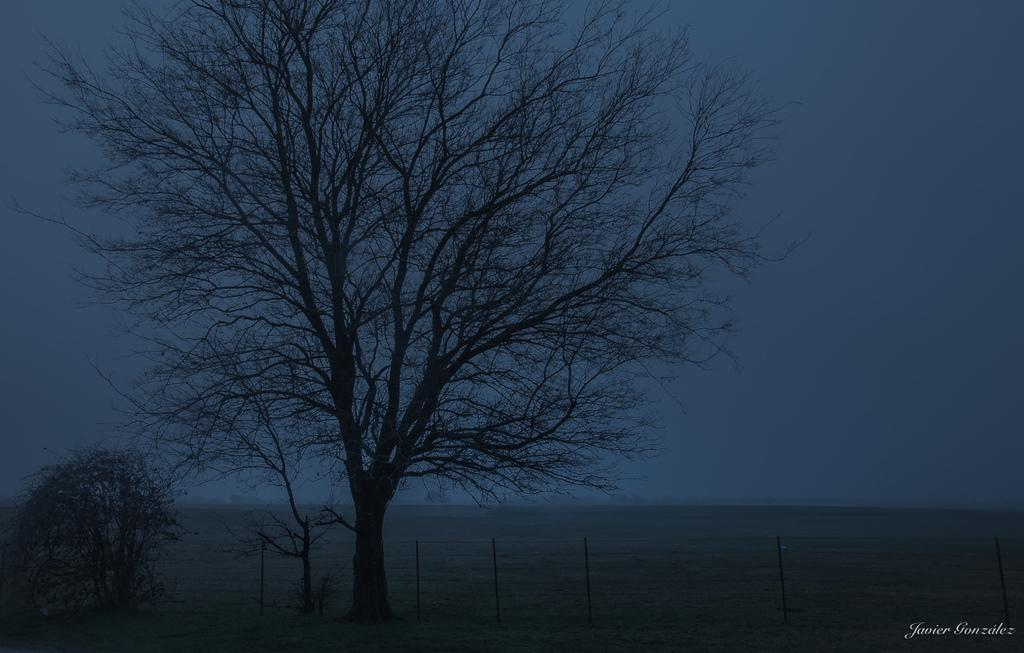What type of vegetation can be seen in the image? There are trees in the image. What is visible at the top of the image? The sky is visible at the top of the image. Can you describe any additional features of the image? There is a watermark at the bottom of the image. Can you see a monkey swinging from the trees in the image? No, there is no monkey present in the image. What type of machine can be seen operating in the image? There is no machine present in the image; it features trees and a sky. 